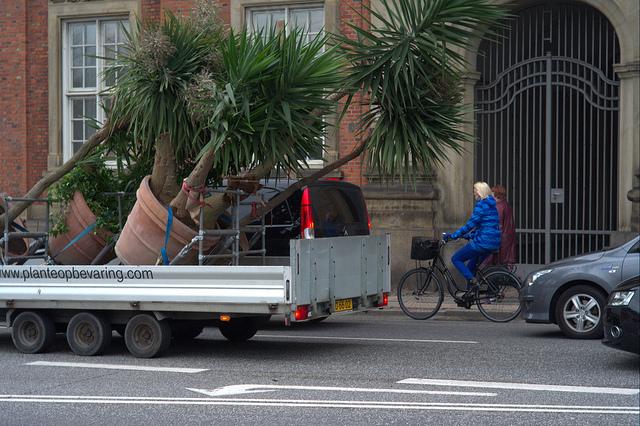Who is riding the bike?
Keep it brief. Woman. What type of trees are on the back of the truck?
Answer briefly. Palm. What is on the truck?
Answer briefly. Trees. 